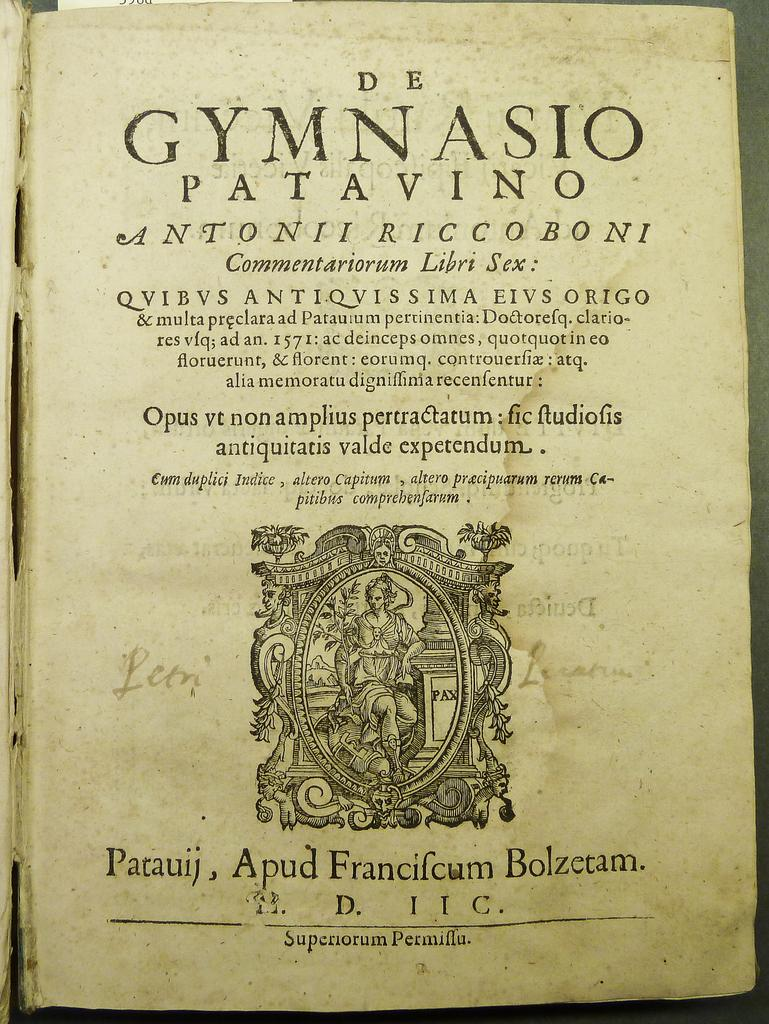<image>
Share a concise interpretation of the image provided. a page in a book that says 'de gymnasio patavino ' at the top 